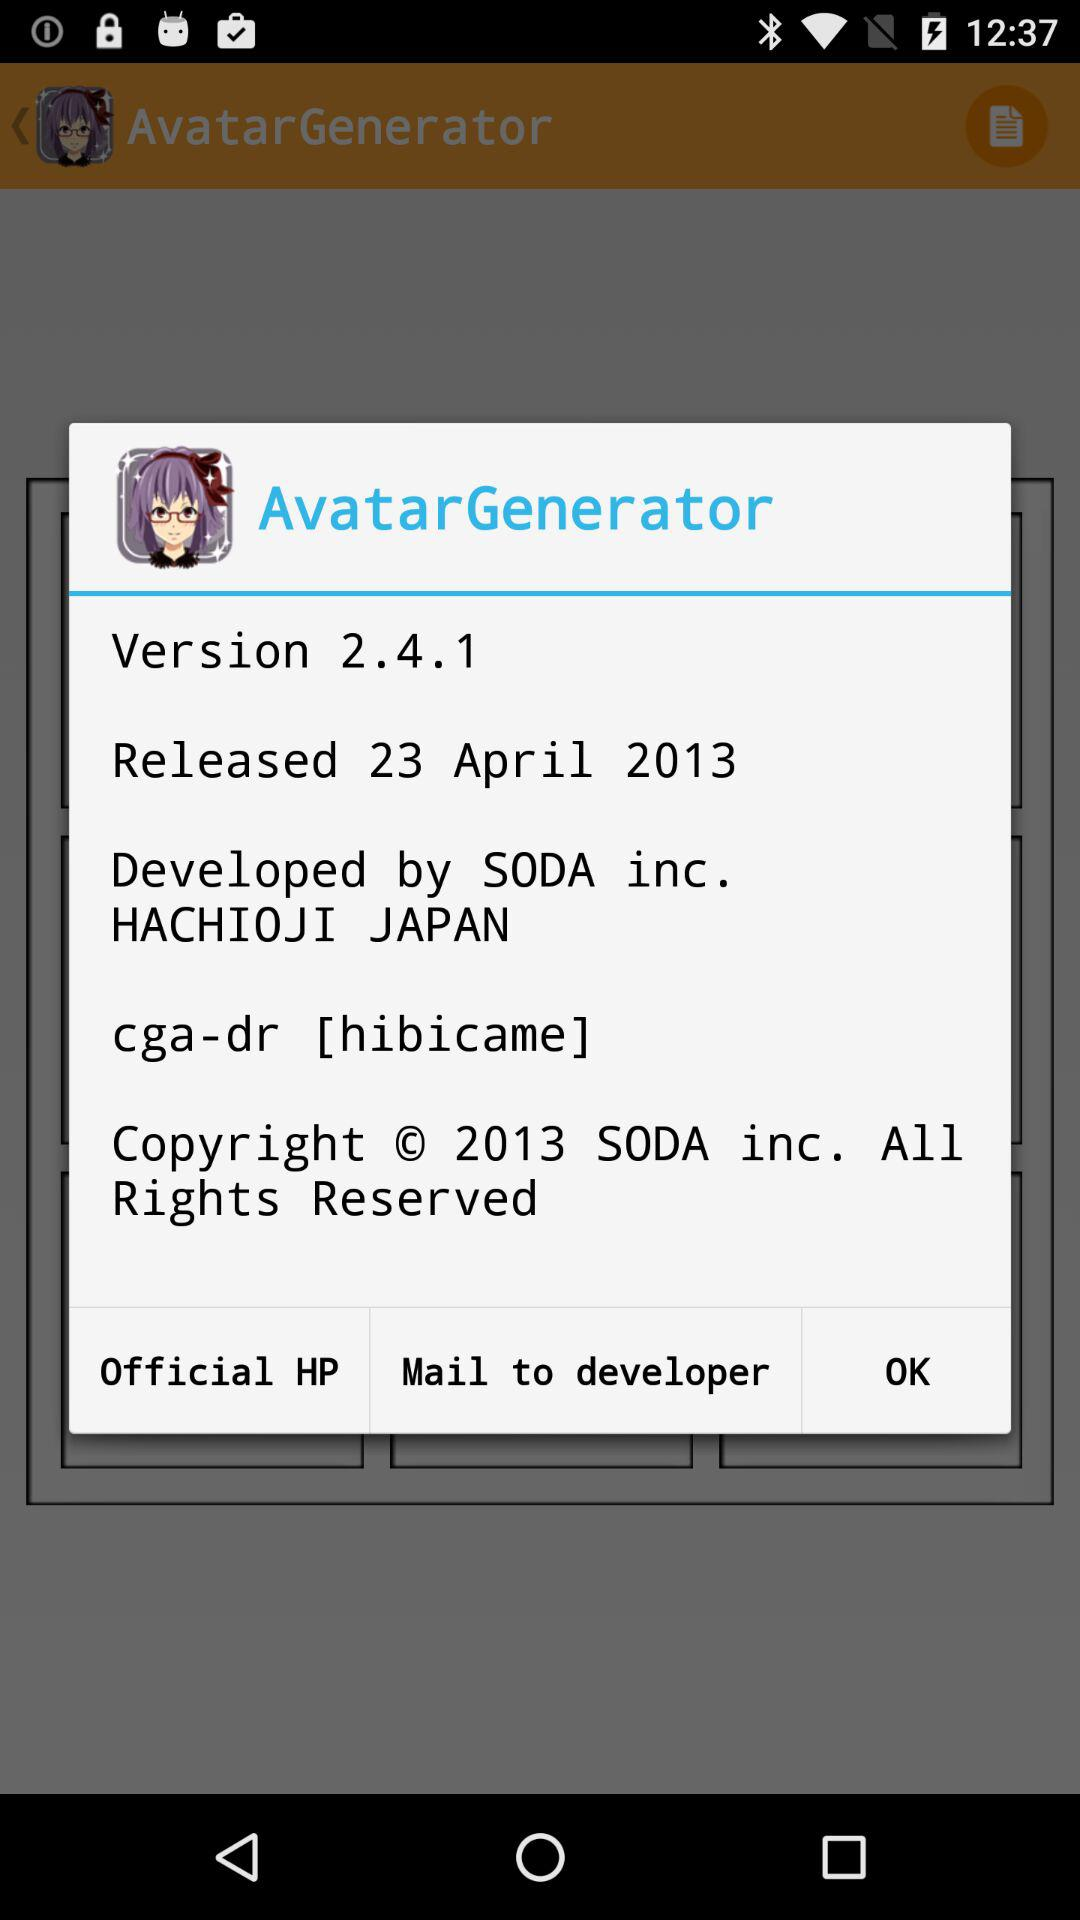What's the release date of the application? The release date of the application is April 23, 2013. 